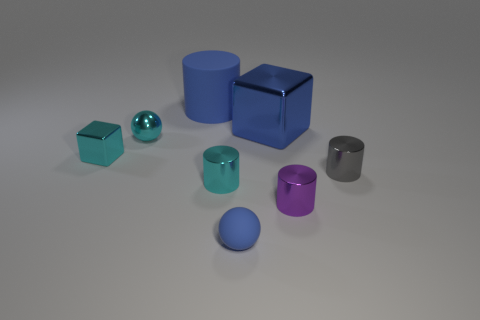What number of other things are there of the same size as the shiny sphere?
Keep it short and to the point. 5. Are the small blue object and the large cube made of the same material?
Make the answer very short. No. What is the color of the metallic block on the right side of the metallic block in front of the small metallic sphere?
Your answer should be compact. Blue. The other shiny thing that is the same shape as the blue metallic thing is what size?
Provide a succinct answer. Small. Is the color of the tiny shiny ball the same as the small shiny block?
Make the answer very short. Yes. How many objects are to the right of the rubber object that is behind the sphere that is behind the tiny matte sphere?
Your response must be concise. 5. Are there more blue metallic cubes than big red metallic balls?
Make the answer very short. Yes. What number of tiny matte spheres are there?
Offer a terse response. 1. What is the shape of the blue object that is in front of the big thing that is in front of the blue thing that is to the left of the small blue matte object?
Give a very brief answer. Sphere. Is the number of tiny metallic things that are in front of the tiny blue rubber object less than the number of large blue objects that are in front of the large rubber thing?
Give a very brief answer. Yes. 